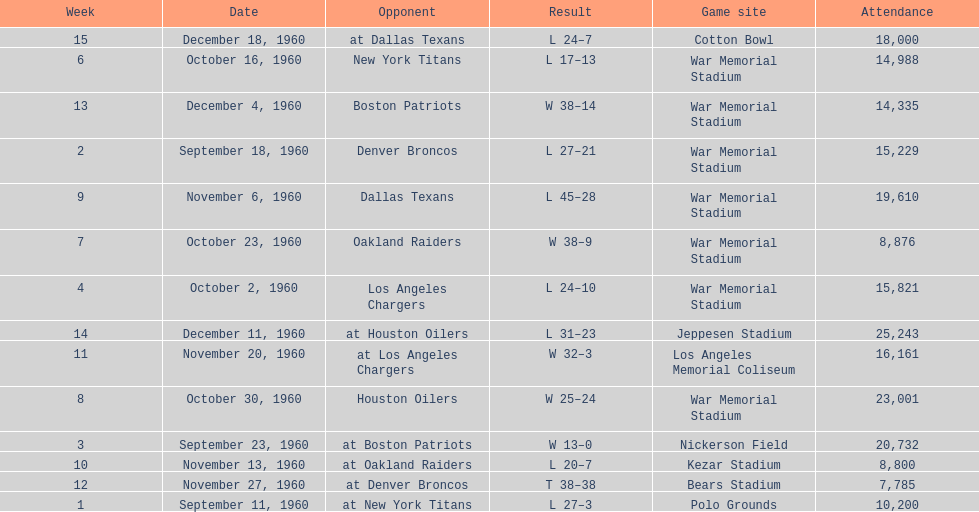Who did the bills play after the oakland raiders? Houston Oilers. 